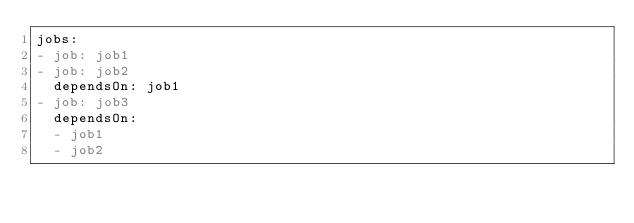Convert code to text. <code><loc_0><loc_0><loc_500><loc_500><_YAML_>jobs:
- job: job1
- job: job2
  dependsOn: job1
- job: job3
  dependsOn:
  - job1
  - job2</code> 